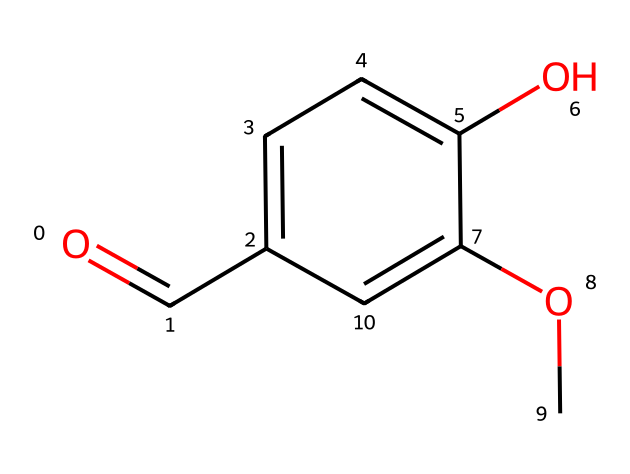What is the molecular formula of vanillin? To determine the molecular formula, count the atoms of each element present in the structure. The SMILES notation shows that there are 8 carbons (C), 8 hydrogens (H), and 3 oxygens (O). Therefore, the molecular formula is C8H8O3.
Answer: C8H8O3 How many rings are present in the structure? Analyze the structure for the presence of cyclic arrangements. The SMILES representation indicates there are no closed loops or rings; the structure is entirely linear with just one aromatic ring. Therefore, the number of rings is zero.
Answer: 0 Which functional groups are present in vanillin? To identify the functional groups, examine the structure for distinctive arrangements. The SMILES shows a carbonyl group (aldehyde) due to the O=C notation and a hydroxyl group (-OH) as well as a methoxy group (-OCH3). Therefore, vanillin contains an aldehyde, a hydroxyl, and a methoxy functional group.
Answer: aldehyde, hydroxyl, methoxy What type of chemical compound is vanillin classified as? Vanillin is categorized based on its structure. The presence of a phenolic structure (benzene ring with substituents) alongside carbonyl and hydroxyl groups indicates it is classified as a phenolic aldehyde. Thus, it is a flavoring agent and a naturally occurring aromatic compound.
Answer: phenolic aldehyde What taste is commonly associated with vanillin? Vanillin is known primarily for its flavor, which is closely linked to the taste of vanilla. This connection is due to the compound’s sensory properties stemming from its chemical structure and functional groups that stimulate sweet flavor receptors on the tongue.
Answer: sweet How does the methoxy group influence the aroma of vanillin? The methoxy group (-OCH3) in vanillin is important for enhancing its aroma profile. This group contributes to the overall sweetness and complexity of the scent, making it more inviting and pleasant. Through electronic effects, it can also stabilize the aromaticity of the molecule, further enriching its olfactory characteristics.
Answer: enhances aroma 